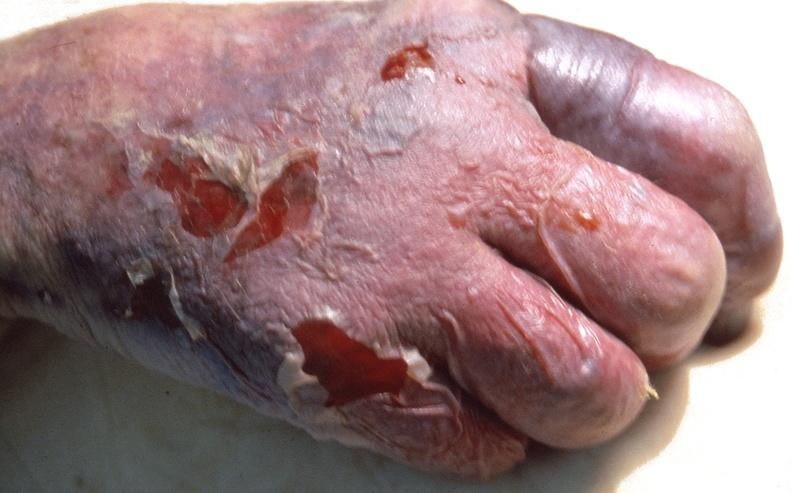does this image show skin ulceration and necrosis, disseminated intravascular coagulation due to acetaminophen toxicity?
Answer the question using a single word or phrase. Yes 